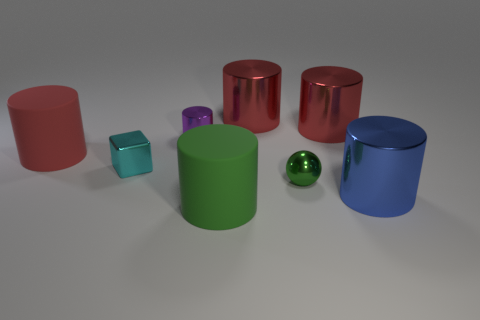Can you describe the texture and material appearance of the objects in the scene? Certainly! The objects in the image have a smooth, reflective surface which suggests they are made of polished metal or plastic with metallic paint. The light reflects off the surfaces, creating highlights and giving them a glossy appearance. 